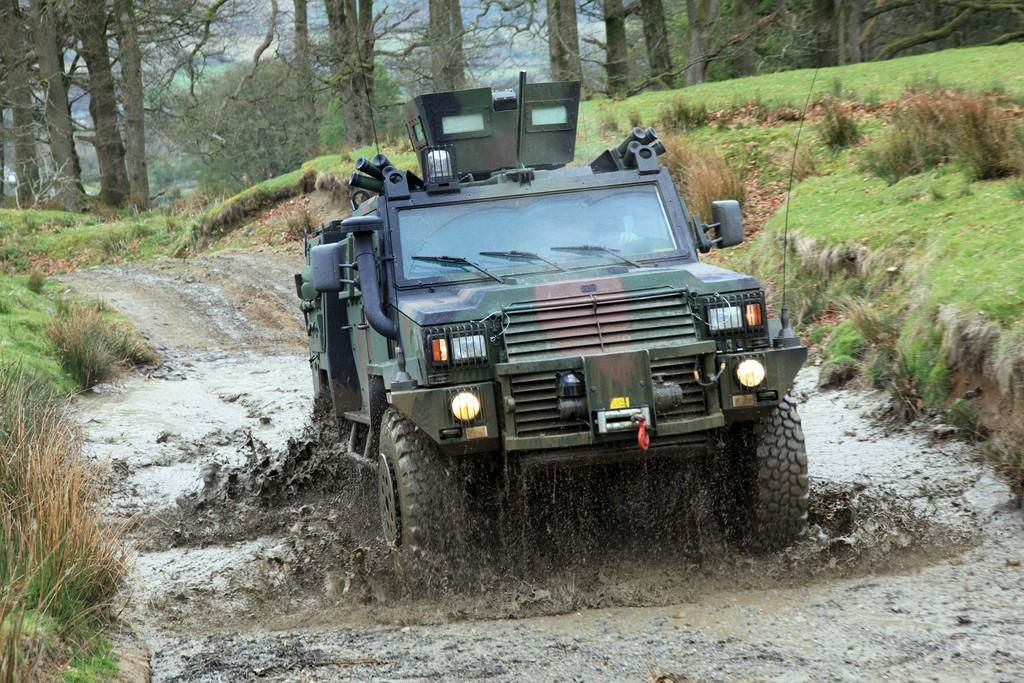What is the main subject of the image? There is a vehicle in the image. What is the condition of the vehicle in the image? The vehicle is in the mud. What type of natural environment is visible in the image? There are trees and grass in the image. What type of drug is being administered to the minister in the image? There is no minister or drug present in the image; it features a vehicle in the mud with trees and grass in the background. 